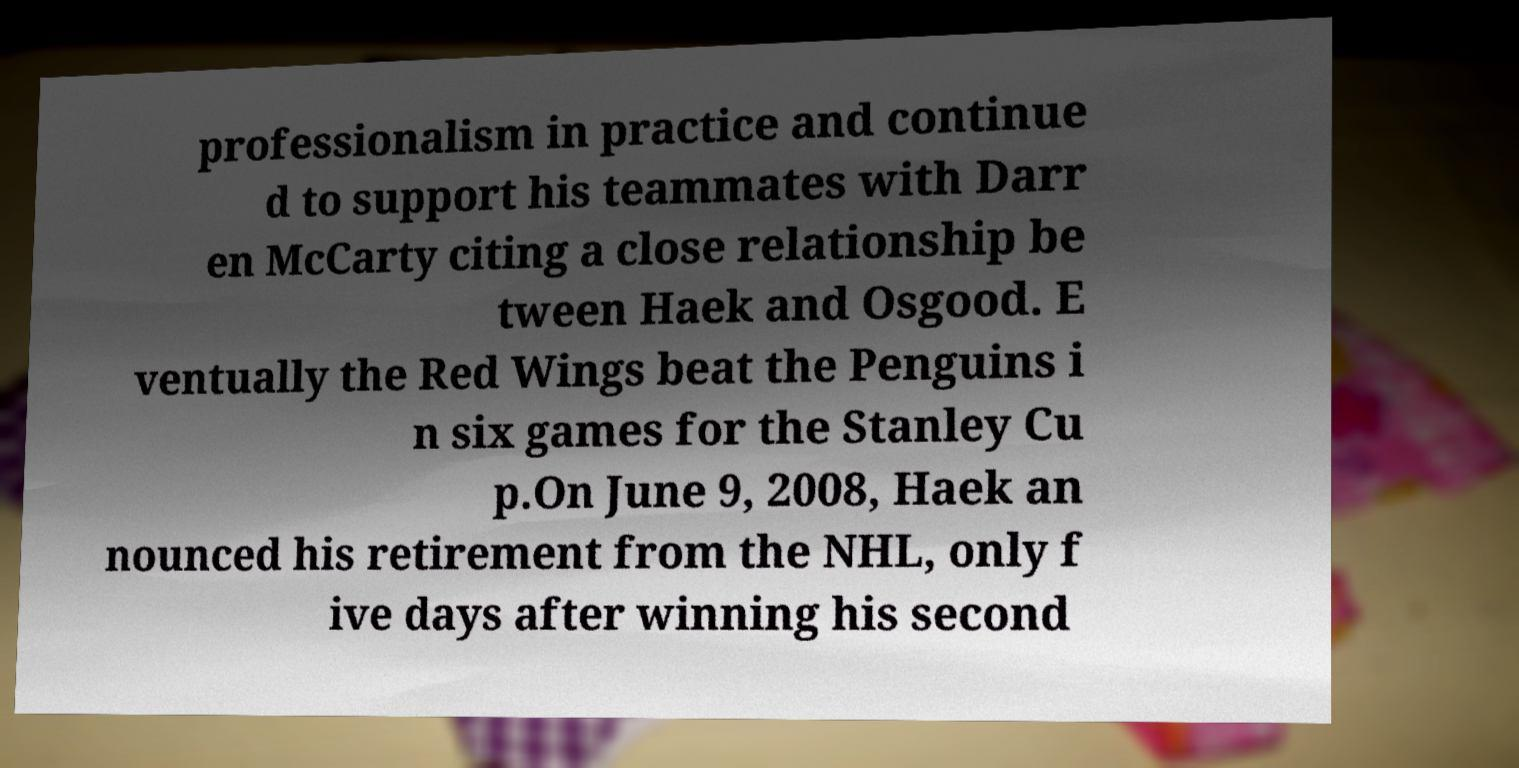Could you extract and type out the text from this image? professionalism in practice and continue d to support his teammates with Darr en McCarty citing a close relationship be tween Haek and Osgood. E ventually the Red Wings beat the Penguins i n six games for the Stanley Cu p.On June 9, 2008, Haek an nounced his retirement from the NHL, only f ive days after winning his second 